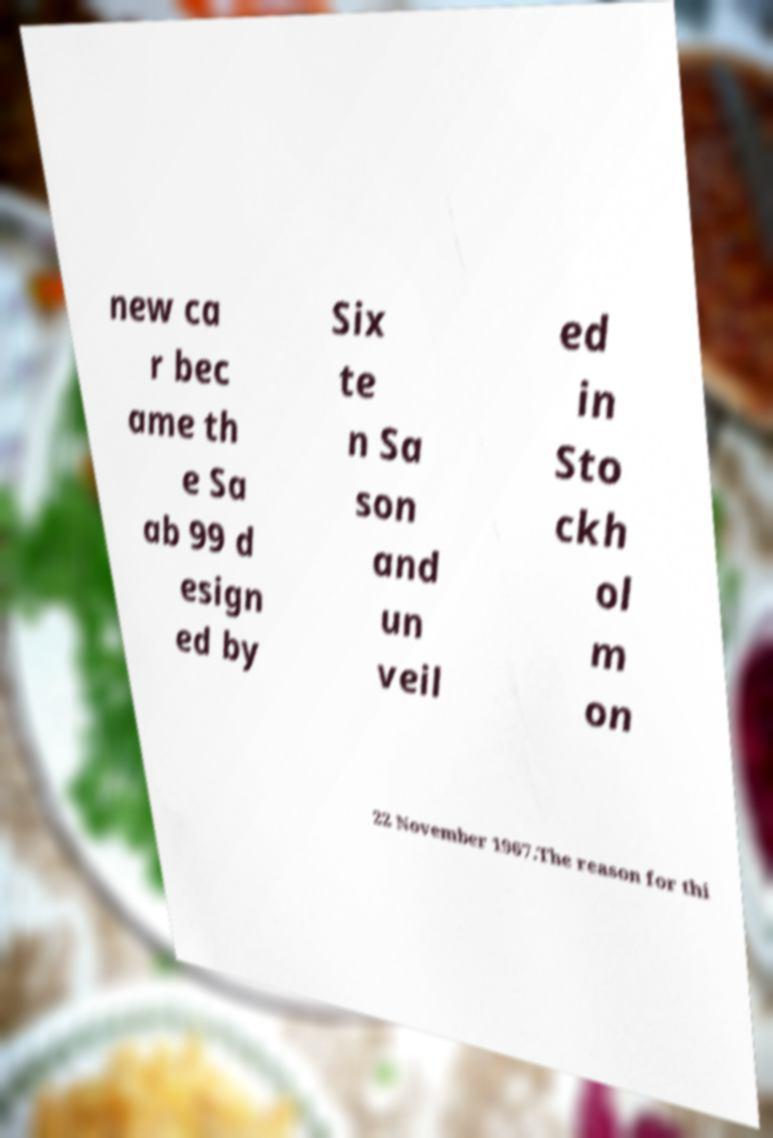Can you read and provide the text displayed in the image?This photo seems to have some interesting text. Can you extract and type it out for me? new ca r bec ame th e Sa ab 99 d esign ed by Six te n Sa son and un veil ed in Sto ckh ol m on 22 November 1967.The reason for thi 